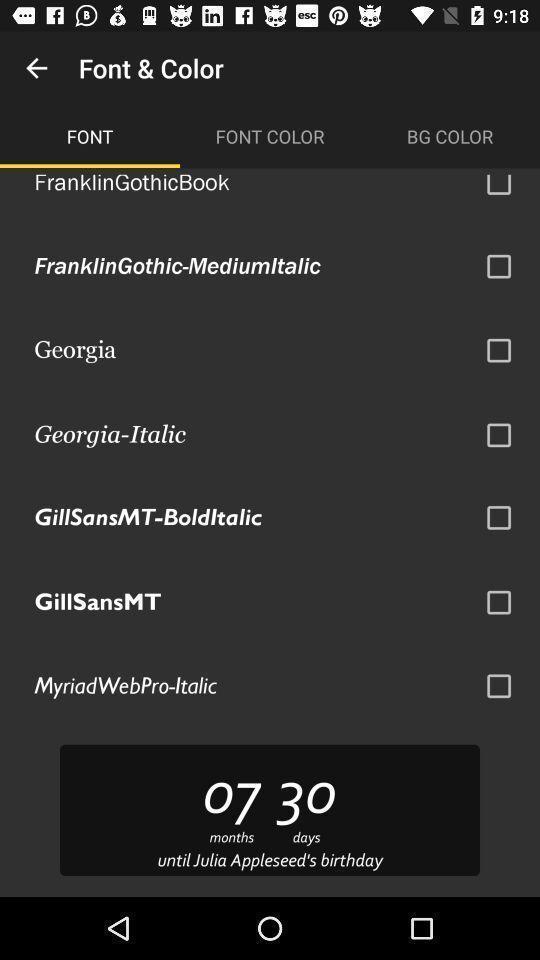Describe this image in words. Settings page for setting font and color. 